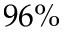<formula> <loc_0><loc_0><loc_500><loc_500>9 6 \%</formula> 